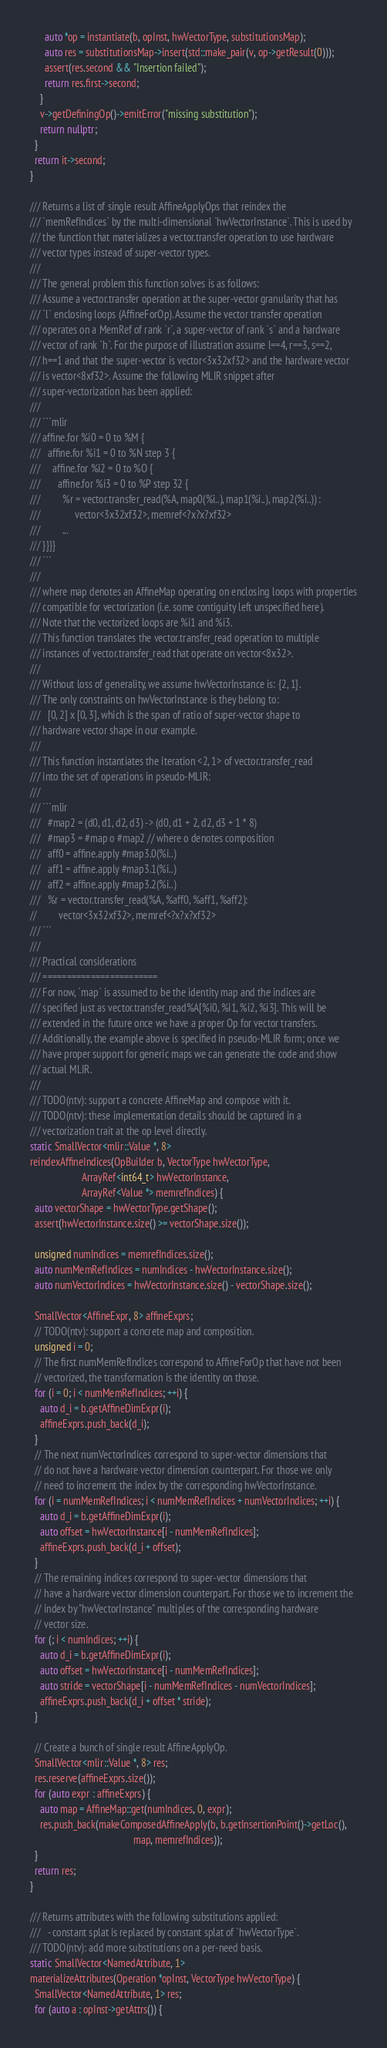Convert code to text. <code><loc_0><loc_0><loc_500><loc_500><_C++_>      auto *op = instantiate(b, opInst, hwVectorType, substitutionsMap);
      auto res = substitutionsMap->insert(std::make_pair(v, op->getResult(0)));
      assert(res.second && "Insertion failed");
      return res.first->second;
    }
    v->getDefiningOp()->emitError("missing substitution");
    return nullptr;
  }
  return it->second;
}

/// Returns a list of single result AffineApplyOps that reindex the
/// `memRefIndices` by the multi-dimensional `hwVectorInstance`. This is used by
/// the function that materializes a vector.transfer operation to use hardware
/// vector types instead of super-vector types.
///
/// The general problem this function solves is as follows:
/// Assume a vector.transfer operation at the super-vector granularity that has
/// `l` enclosing loops (AffineForOp). Assume the vector transfer operation
/// operates on a MemRef of rank `r`, a super-vector of rank `s` and a hardware
/// vector of rank `h`. For the purpose of illustration assume l==4, r==3, s==2,
/// h==1 and that the super-vector is vector<3x32xf32> and the hardware vector
/// is vector<8xf32>. Assume the following MLIR snippet after
/// super-vectorization has been applied:
///
/// ```mlir
/// affine.for %i0 = 0 to %M {
///   affine.for %i1 = 0 to %N step 3 {
///     affine.for %i2 = 0 to %O {
///       affine.for %i3 = 0 to %P step 32 {
///         %r = vector.transfer_read(%A, map0(%i..), map1(%i..), map2(%i..)) :
///              vector<3x32xf32>, memref<?x?x?xf32>
///         ...
/// }}}}
/// ```
///
/// where map denotes an AffineMap operating on enclosing loops with properties
/// compatible for vectorization (i.e. some contiguity left unspecified here).
/// Note that the vectorized loops are %i1 and %i3.
/// This function translates the vector.transfer_read operation to multiple
/// instances of vector.transfer_read that operate on vector<8x32>.
///
/// Without loss of generality, we assume hwVectorInstance is: {2, 1}.
/// The only constraints on hwVectorInstance is they belong to:
///   [0, 2] x [0, 3], which is the span of ratio of super-vector shape to
/// hardware vector shape in our example.
///
/// This function instantiates the iteration <2, 1> of vector.transfer_read
/// into the set of operations in pseudo-MLIR:
///
/// ```mlir
///   #map2 = (d0, d1, d2, d3) -> (d0, d1 + 2, d2, d3 + 1 * 8)
///   #map3 = #map o #map2 // where o denotes composition
///   aff0 = affine.apply #map3.0(%i..)
///   aff1 = affine.apply #map3.1(%i..)
///   aff2 = affine.apply #map3.2(%i..)
///   %r = vector.transfer_read(%A, %aff0, %aff1, %aff2):
//         vector<3x32xf32>, memref<?x?x?xf32>
/// ```
///
/// Practical considerations
/// ========================
/// For now, `map` is assumed to be the identity map and the indices are
/// specified just as vector.transfer_read%A[%i0, %i1, %i2, %i3]. This will be
/// extended in the future once we have a proper Op for vector transfers.
/// Additionally, the example above is specified in pseudo-MLIR form; once we
/// have proper support for generic maps we can generate the code and show
/// actual MLIR.
///
/// TODO(ntv): support a concrete AffineMap and compose with it.
/// TODO(ntv): these implementation details should be captured in a
/// vectorization trait at the op level directly.
static SmallVector<mlir::Value *, 8>
reindexAffineIndices(OpBuilder b, VectorType hwVectorType,
                     ArrayRef<int64_t> hwVectorInstance,
                     ArrayRef<Value *> memrefIndices) {
  auto vectorShape = hwVectorType.getShape();
  assert(hwVectorInstance.size() >= vectorShape.size());

  unsigned numIndices = memrefIndices.size();
  auto numMemRefIndices = numIndices - hwVectorInstance.size();
  auto numVectorIndices = hwVectorInstance.size() - vectorShape.size();

  SmallVector<AffineExpr, 8> affineExprs;
  // TODO(ntv): support a concrete map and composition.
  unsigned i = 0;
  // The first numMemRefIndices correspond to AffineForOp that have not been
  // vectorized, the transformation is the identity on those.
  for (i = 0; i < numMemRefIndices; ++i) {
    auto d_i = b.getAffineDimExpr(i);
    affineExprs.push_back(d_i);
  }
  // The next numVectorIndices correspond to super-vector dimensions that
  // do not have a hardware vector dimension counterpart. For those we only
  // need to increment the index by the corresponding hwVectorInstance.
  for (i = numMemRefIndices; i < numMemRefIndices + numVectorIndices; ++i) {
    auto d_i = b.getAffineDimExpr(i);
    auto offset = hwVectorInstance[i - numMemRefIndices];
    affineExprs.push_back(d_i + offset);
  }
  // The remaining indices correspond to super-vector dimensions that
  // have a hardware vector dimension counterpart. For those we to increment the
  // index by "hwVectorInstance" multiples of the corresponding hardware
  // vector size.
  for (; i < numIndices; ++i) {
    auto d_i = b.getAffineDimExpr(i);
    auto offset = hwVectorInstance[i - numMemRefIndices];
    auto stride = vectorShape[i - numMemRefIndices - numVectorIndices];
    affineExprs.push_back(d_i + offset * stride);
  }

  // Create a bunch of single result AffineApplyOp.
  SmallVector<mlir::Value *, 8> res;
  res.reserve(affineExprs.size());
  for (auto expr : affineExprs) {
    auto map = AffineMap::get(numIndices, 0, expr);
    res.push_back(makeComposedAffineApply(b, b.getInsertionPoint()->getLoc(),
                                          map, memrefIndices));
  }
  return res;
}

/// Returns attributes with the following substitutions applied:
///   - constant splat is replaced by constant splat of `hwVectorType`.
/// TODO(ntv): add more substitutions on a per-need basis.
static SmallVector<NamedAttribute, 1>
materializeAttributes(Operation *opInst, VectorType hwVectorType) {
  SmallVector<NamedAttribute, 1> res;
  for (auto a : opInst->getAttrs()) {</code> 